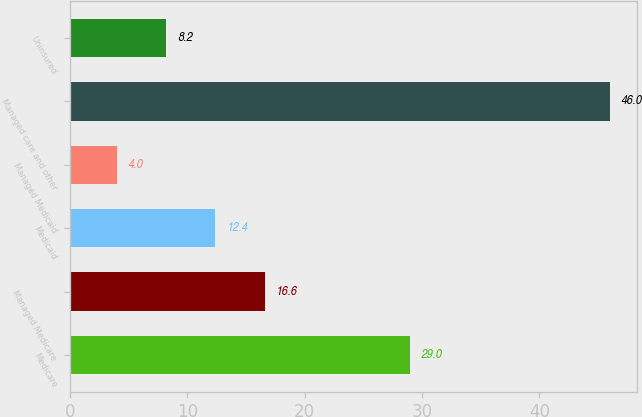Convert chart. <chart><loc_0><loc_0><loc_500><loc_500><bar_chart><fcel>Medicare<fcel>Managed Medicare<fcel>Medicaid<fcel>Managed Medicaid<fcel>Managed care and other<fcel>Uninsured<nl><fcel>29<fcel>16.6<fcel>12.4<fcel>4<fcel>46<fcel>8.2<nl></chart> 